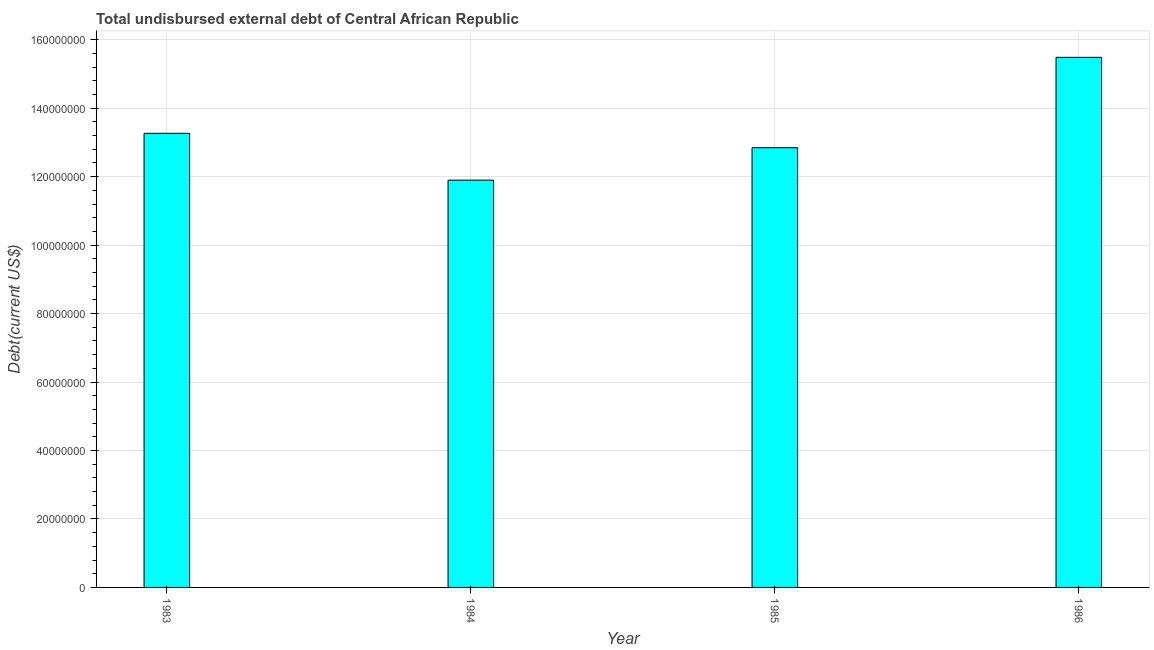Does the graph contain any zero values?
Offer a terse response. No. Does the graph contain grids?
Provide a succinct answer. Yes. What is the title of the graph?
Your answer should be compact. Total undisbursed external debt of Central African Republic. What is the label or title of the Y-axis?
Provide a short and direct response. Debt(current US$). What is the total debt in 1985?
Offer a very short reply. 1.28e+08. Across all years, what is the maximum total debt?
Offer a terse response. 1.55e+08. Across all years, what is the minimum total debt?
Provide a succinct answer. 1.19e+08. In which year was the total debt minimum?
Give a very brief answer. 1984. What is the sum of the total debt?
Your answer should be very brief. 5.35e+08. What is the difference between the total debt in 1984 and 1986?
Your response must be concise. -3.59e+07. What is the average total debt per year?
Offer a very short reply. 1.34e+08. What is the median total debt?
Make the answer very short. 1.31e+08. What is the ratio of the total debt in 1984 to that in 1986?
Your response must be concise. 0.77. Is the difference between the total debt in 1985 and 1986 greater than the difference between any two years?
Make the answer very short. No. What is the difference between the highest and the second highest total debt?
Ensure brevity in your answer.  2.22e+07. What is the difference between the highest and the lowest total debt?
Provide a succinct answer. 3.59e+07. In how many years, is the total debt greater than the average total debt taken over all years?
Give a very brief answer. 1. How many bars are there?
Ensure brevity in your answer.  4. Are all the bars in the graph horizontal?
Provide a succinct answer. No. What is the difference between two consecutive major ticks on the Y-axis?
Provide a succinct answer. 2.00e+07. Are the values on the major ticks of Y-axis written in scientific E-notation?
Keep it short and to the point. No. What is the Debt(current US$) in 1983?
Ensure brevity in your answer.  1.33e+08. What is the Debt(current US$) in 1984?
Offer a very short reply. 1.19e+08. What is the Debt(current US$) in 1985?
Provide a succinct answer. 1.28e+08. What is the Debt(current US$) of 1986?
Make the answer very short. 1.55e+08. What is the difference between the Debt(current US$) in 1983 and 1984?
Keep it short and to the point. 1.37e+07. What is the difference between the Debt(current US$) in 1983 and 1985?
Ensure brevity in your answer.  4.21e+06. What is the difference between the Debt(current US$) in 1983 and 1986?
Keep it short and to the point. -2.22e+07. What is the difference between the Debt(current US$) in 1984 and 1985?
Your answer should be very brief. -9.47e+06. What is the difference between the Debt(current US$) in 1984 and 1986?
Make the answer very short. -3.59e+07. What is the difference between the Debt(current US$) in 1985 and 1986?
Your answer should be compact. -2.64e+07. What is the ratio of the Debt(current US$) in 1983 to that in 1984?
Ensure brevity in your answer.  1.11. What is the ratio of the Debt(current US$) in 1983 to that in 1985?
Provide a short and direct response. 1.03. What is the ratio of the Debt(current US$) in 1983 to that in 1986?
Your response must be concise. 0.86. What is the ratio of the Debt(current US$) in 1984 to that in 1985?
Give a very brief answer. 0.93. What is the ratio of the Debt(current US$) in 1984 to that in 1986?
Provide a succinct answer. 0.77. What is the ratio of the Debt(current US$) in 1985 to that in 1986?
Ensure brevity in your answer.  0.83. 